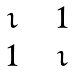Convert formula to latex. <formula><loc_0><loc_0><loc_500><loc_500>\begin{matrix} \imath & \, & 1 \\ 1 & \, & \imath \end{matrix}</formula> 